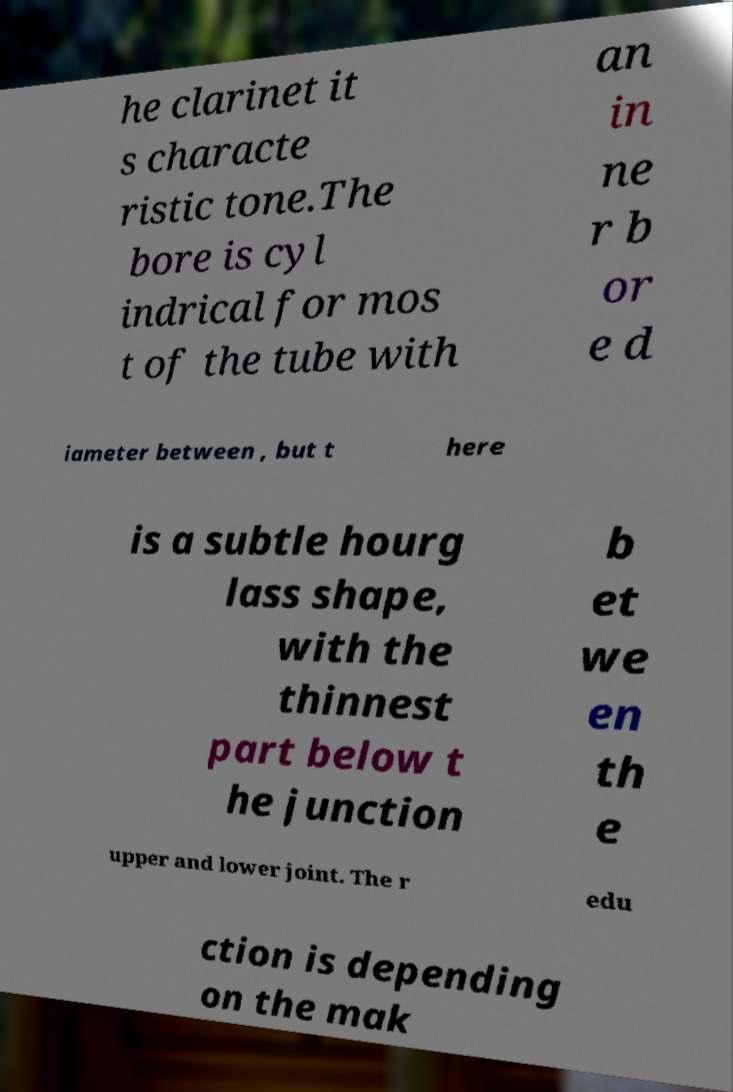There's text embedded in this image that I need extracted. Can you transcribe it verbatim? he clarinet it s characte ristic tone.The bore is cyl indrical for mos t of the tube with an in ne r b or e d iameter between , but t here is a subtle hourg lass shape, with the thinnest part below t he junction b et we en th e upper and lower joint. The r edu ction is depending on the mak 